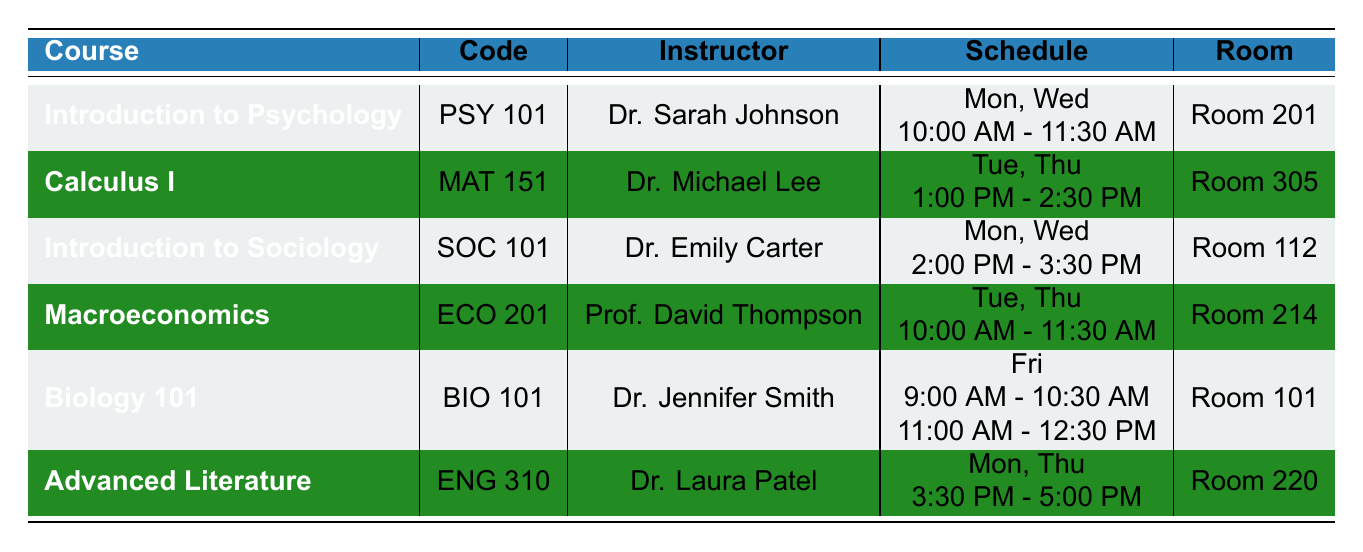What is the course code for Advanced Literature? The table shows the courses along with their respective codes. Looking at the row for Advanced Literature, the course code listed is ENG 310.
Answer: ENG 310 Which instructor teaches Introduction to Sociology? In the table, under the course "Introduction to Sociology", the instructor is noted as Dr. Emily Carter.
Answer: Dr. Emily Carter How many different rooms are used for classes on Fridays? On Friday, there is one course titled Biology 101, which uses Room 101 for two different time slots. Thus, the number of different rooms used on Fridays is 1.
Answer: 1 Which course has classes scheduled at 10:00 AM on Tuesdays? By reviewing the schedule in the table, the course "Macroeconomics" is scheduled at 10:00 AM on Tuesdays, in Room 214.
Answer: Macroeconomics Is there a course scheduled on both Monday and Wednesday? The table shows several courses, and both "Introduction to Psychology" and "Introduction to Sociology" have classes on Monday and Wednesday. Therefore, the answer is yes.
Answer: Yes What is the total number of classes held for Biology 101? The table indicates that Biology 101 has two separate time slots on Friday: one from 9:00 AM to 10:30 AM and another from 11:00 AM to 12:30 PM. Thus, the total number of classes for Biology 101 is 2.
Answer: 2 Which course is taught by Dr. Laura Patel, and what days are the classes held? Looking at the table under the instructor column, Dr. Laura Patel teaches Advanced Literature, with classes scheduled on Monday and Thursday.
Answer: Advanced Literature; Monday, Thursday What is the time duration for each class session of Calculus I? The schedule for Calculus I indicates that the classes are held on Tuesday and Thursday from 1:00 PM to 2:30 PM. This represents a time duration of 1.5 hours per class session.
Answer: 1.5 hours Which course has overlapping classes occurring at the same time as the end of another course? By analyzing the schedule, Advanced Literature ends at 5:00 PM on Monday while the next class on the same day (if any) does not compete for that time slot. However, since no other classes are scheduled at that exact time, there’s no overlap.
Answer: No overlap How many classes are scheduled to take place in Room 214? The table indicates that the course "Macroeconomics" is scheduled twice a week (Tuesday and Thursday) in Room 214. Thus, there are 2 classes scheduled in this room.
Answer: 2 